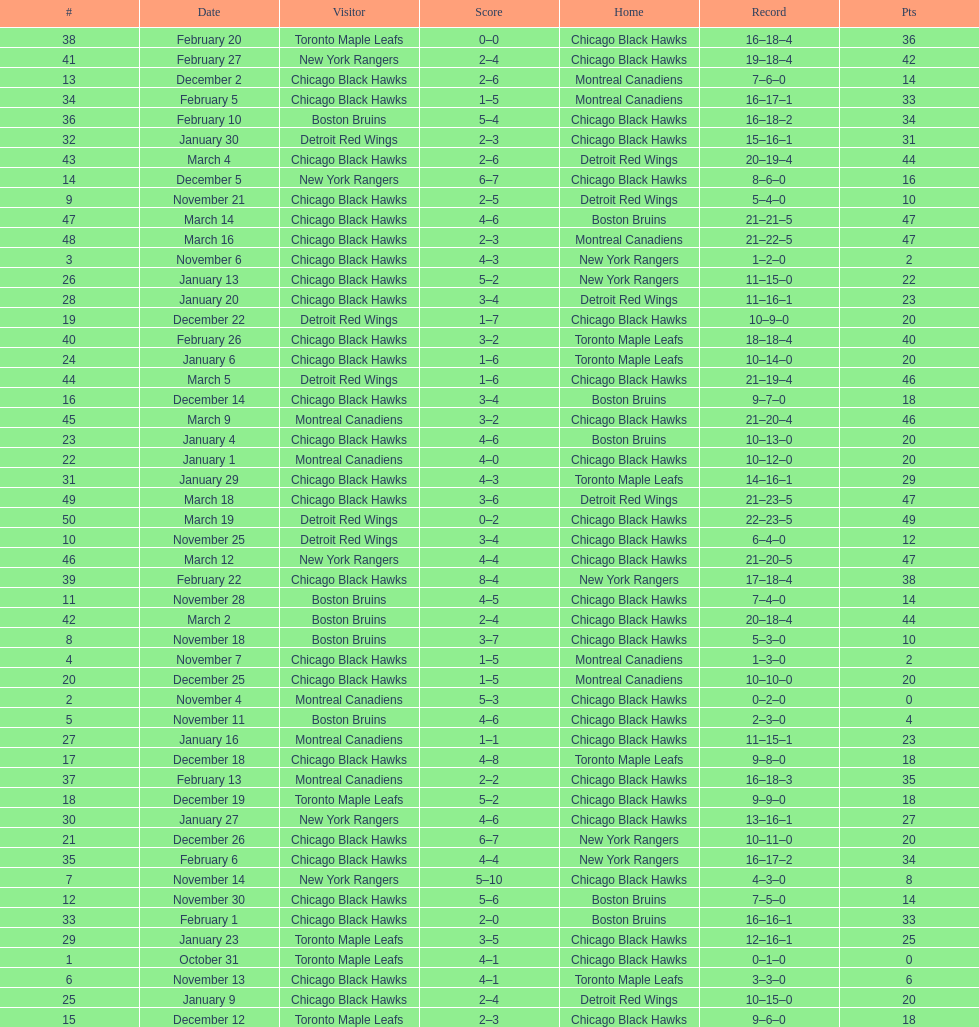Which team was the first one the black hawks lost to? Toronto Maple Leafs. I'm looking to parse the entire table for insights. Could you assist me with that? {'header': ['#', 'Date', 'Visitor', 'Score', 'Home', 'Record', 'Pts'], 'rows': [['38', 'February 20', 'Toronto Maple Leafs', '0–0', 'Chicago Black Hawks', '16–18–4', '36'], ['41', 'February 27', 'New York Rangers', '2–4', 'Chicago Black Hawks', '19–18–4', '42'], ['13', 'December 2', 'Chicago Black Hawks', '2–6', 'Montreal Canadiens', '7–6–0', '14'], ['34', 'February 5', 'Chicago Black Hawks', '1–5', 'Montreal Canadiens', '16–17–1', '33'], ['36', 'February 10', 'Boston Bruins', '5–4', 'Chicago Black Hawks', '16–18–2', '34'], ['32', 'January 30', 'Detroit Red Wings', '2–3', 'Chicago Black Hawks', '15–16–1', '31'], ['43', 'March 4', 'Chicago Black Hawks', '2–6', 'Detroit Red Wings', '20–19–4', '44'], ['14', 'December 5', 'New York Rangers', '6–7', 'Chicago Black Hawks', '8–6–0', '16'], ['9', 'November 21', 'Chicago Black Hawks', '2–5', 'Detroit Red Wings', '5–4–0', '10'], ['47', 'March 14', 'Chicago Black Hawks', '4–6', 'Boston Bruins', '21–21–5', '47'], ['48', 'March 16', 'Chicago Black Hawks', '2–3', 'Montreal Canadiens', '21–22–5', '47'], ['3', 'November 6', 'Chicago Black Hawks', '4–3', 'New York Rangers', '1–2–0', '2'], ['26', 'January 13', 'Chicago Black Hawks', '5–2', 'New York Rangers', '11–15–0', '22'], ['28', 'January 20', 'Chicago Black Hawks', '3–4', 'Detroit Red Wings', '11–16–1', '23'], ['19', 'December 22', 'Detroit Red Wings', '1–7', 'Chicago Black Hawks', '10–9–0', '20'], ['40', 'February 26', 'Chicago Black Hawks', '3–2', 'Toronto Maple Leafs', '18–18–4', '40'], ['24', 'January 6', 'Chicago Black Hawks', '1–6', 'Toronto Maple Leafs', '10–14–0', '20'], ['44', 'March 5', 'Detroit Red Wings', '1–6', 'Chicago Black Hawks', '21–19–4', '46'], ['16', 'December 14', 'Chicago Black Hawks', '3–4', 'Boston Bruins', '9–7–0', '18'], ['45', 'March 9', 'Montreal Canadiens', '3–2', 'Chicago Black Hawks', '21–20–4', '46'], ['23', 'January 4', 'Chicago Black Hawks', '4–6', 'Boston Bruins', '10–13–0', '20'], ['22', 'January 1', 'Montreal Canadiens', '4–0', 'Chicago Black Hawks', '10–12–0', '20'], ['31', 'January 29', 'Chicago Black Hawks', '4–3', 'Toronto Maple Leafs', '14–16–1', '29'], ['49', 'March 18', 'Chicago Black Hawks', '3–6', 'Detroit Red Wings', '21–23–5', '47'], ['50', 'March 19', 'Detroit Red Wings', '0–2', 'Chicago Black Hawks', '22–23–5', '49'], ['10', 'November 25', 'Detroit Red Wings', '3–4', 'Chicago Black Hawks', '6–4–0', '12'], ['46', 'March 12', 'New York Rangers', '4–4', 'Chicago Black Hawks', '21–20–5', '47'], ['39', 'February 22', 'Chicago Black Hawks', '8–4', 'New York Rangers', '17–18–4', '38'], ['11', 'November 28', 'Boston Bruins', '4–5', 'Chicago Black Hawks', '7–4–0', '14'], ['42', 'March 2', 'Boston Bruins', '2–4', 'Chicago Black Hawks', '20–18–4', '44'], ['8', 'November 18', 'Boston Bruins', '3–7', 'Chicago Black Hawks', '5–3–0', '10'], ['4', 'November 7', 'Chicago Black Hawks', '1–5', 'Montreal Canadiens', '1–3–0', '2'], ['20', 'December 25', 'Chicago Black Hawks', '1–5', 'Montreal Canadiens', '10–10–0', '20'], ['2', 'November 4', 'Montreal Canadiens', '5–3', 'Chicago Black Hawks', '0–2–0', '0'], ['5', 'November 11', 'Boston Bruins', '4–6', 'Chicago Black Hawks', '2–3–0', '4'], ['27', 'January 16', 'Montreal Canadiens', '1–1', 'Chicago Black Hawks', '11–15–1', '23'], ['17', 'December 18', 'Chicago Black Hawks', '4–8', 'Toronto Maple Leafs', '9–8–0', '18'], ['37', 'February 13', 'Montreal Canadiens', '2–2', 'Chicago Black Hawks', '16–18–3', '35'], ['18', 'December 19', 'Toronto Maple Leafs', '5–2', 'Chicago Black Hawks', '9–9–0', '18'], ['30', 'January 27', 'New York Rangers', '4–6', 'Chicago Black Hawks', '13–16–1', '27'], ['21', 'December 26', 'Chicago Black Hawks', '6–7', 'New York Rangers', '10–11–0', '20'], ['35', 'February 6', 'Chicago Black Hawks', '4–4', 'New York Rangers', '16–17–2', '34'], ['7', 'November 14', 'New York Rangers', '5–10', 'Chicago Black Hawks', '4–3–0', '8'], ['12', 'November 30', 'Chicago Black Hawks', '5–6', 'Boston Bruins', '7–5–0', '14'], ['33', 'February 1', 'Chicago Black Hawks', '2–0', 'Boston Bruins', '16–16–1', '33'], ['29', 'January 23', 'Toronto Maple Leafs', '3–5', 'Chicago Black Hawks', '12–16–1', '25'], ['1', 'October 31', 'Toronto Maple Leafs', '4–1', 'Chicago Black Hawks', '0–1–0', '0'], ['6', 'November 13', 'Chicago Black Hawks', '4–1', 'Toronto Maple Leafs', '3–3–0', '6'], ['25', 'January 9', 'Chicago Black Hawks', '2–4', 'Detroit Red Wings', '10–15–0', '20'], ['15', 'December 12', 'Toronto Maple Leafs', '2–3', 'Chicago Black Hawks', '9–6–0', '18']]} 